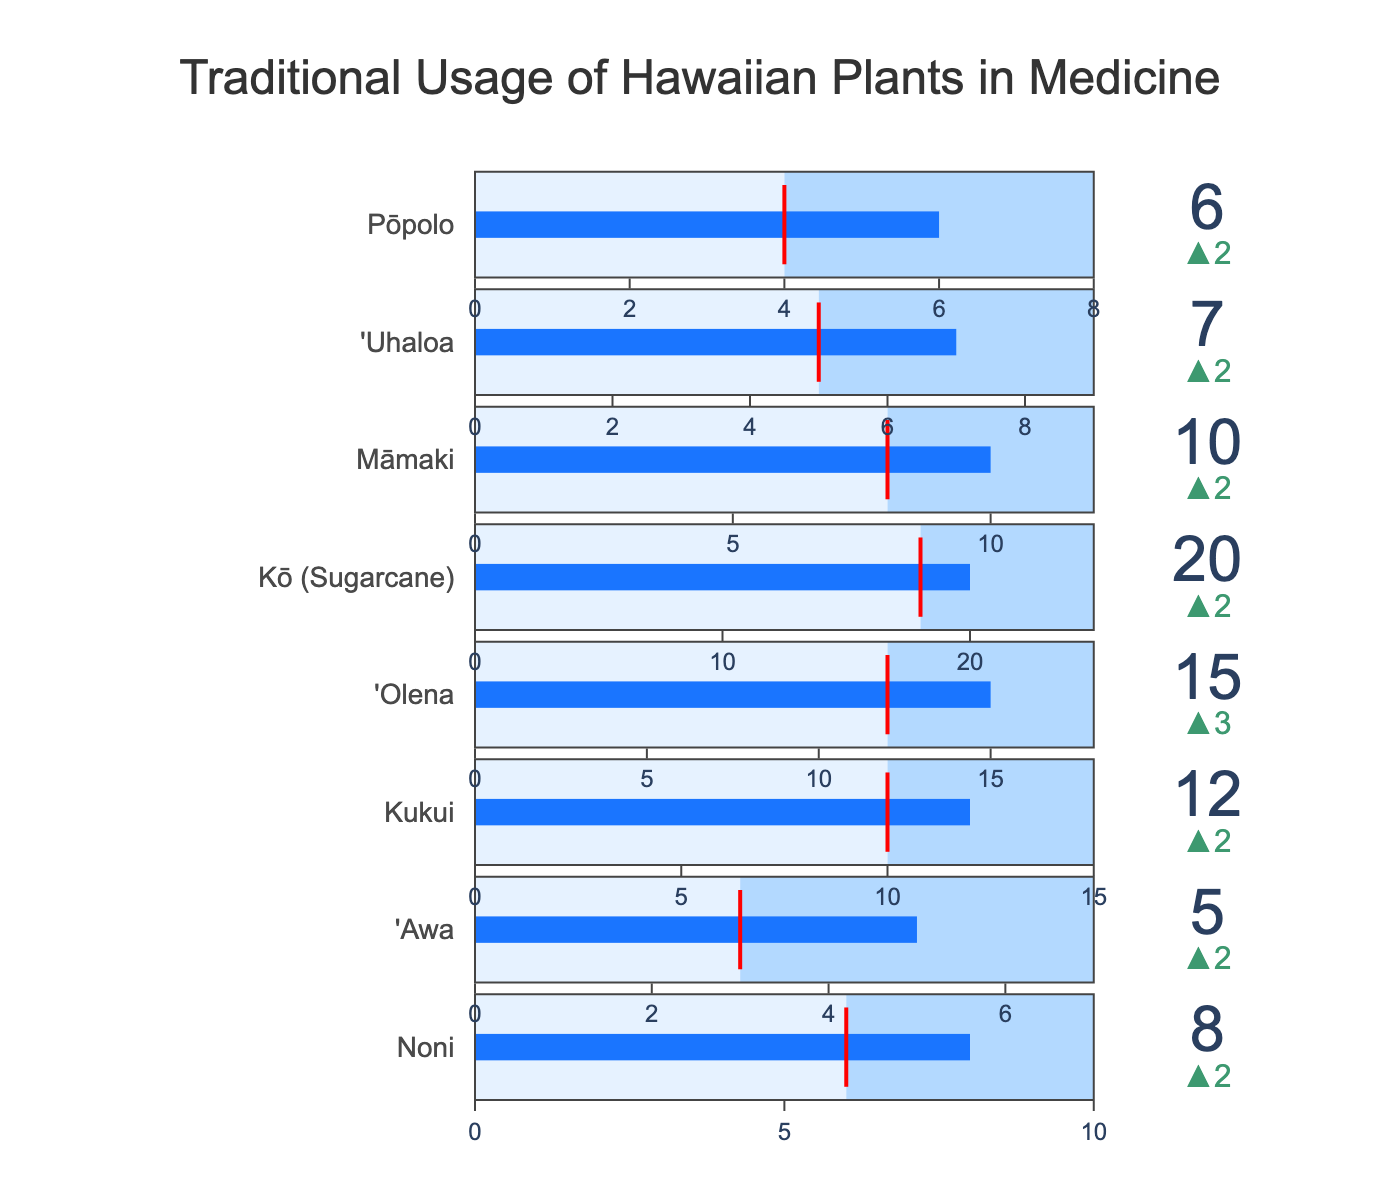what is the title of this figure? The title of the figure is located at the top of the chart. It describes the main subject of the visual representation. By looking at the top of the chart, you will see the text that provides an overview of what the figure is showing.
Answer: Traditional Usage of Hawaiian Plants in Medicine Which plant has the highest actual usage per month? To find the plant with the highest actual usage, compare the values for "Actual Usage (times per month)" for each plant. The plant with the highest value among them is the answer. From the visual data, Kō (Sugarcane) has the highest value.
Answer: Kō (Sugarcane) How many times more is the actual usage than the recommended usage for 'Olena? To determine this, subtract the "Recommended Usage (times per month)" from the "Actual Usage (times per month)" for 'Olena. From the visual data: 15 (Actual) - 12 (Recommended) = 3 times more.
Answer: 3 times more Which plant has the closest actual usage to its recommended usage? To find the plant with the closest actual usage to its recommended usage, calculate the difference between the actual and recommended usage for each plant and find the smallest difference. From the visual data: 'Awa's actual usage is closest to its recommended usage. The difference is 2 (5 - 3).
Answer: 'Awa What is the maximum recommended usage range shown for any plant in the chart? To determine the maximum recommended usage range, look at the maximum usage values of all the plants and find the largest one. The maximum usage range shown is for Kō (Sugarcane), which goes up to 25 times per month.
Answer: 25 times per month Which plant exceeds its recommended usage the most? To determine this, look at the delta values (differences) where the actual usage is higher than the recommended usage and find the largest positive difference. For 'Olena, the actual usage is 15, and the recommended usage is 12. For Kō (Sugarcane), the actual usage is 20, and the recommended usage is 18. The largest positive difference is found by Kō (Sugarcane) with an excess of 2 times.
Answer: Kō (Sugarcane) What is the maximum allowed usage for Kukui? To find the maximum allowed usage for Kukui, look at the value stated in the “Maximum Usage (times per month)” for Kukui. The visual data indicates that the maximum usage for Kukui is 15 times per month.
Answer: 15 times per month What is the difference between actual and recommended usage for Pōpolo? To determine the difference, subtract the recommended usage from the actual usage for Pōpolo. From the visual data: 6 (Actual) - 4 (Recommended) = 2.
Answer: 2 Which plants have actual usage exceeding their maximum allowed usage? To find this, compare the actual usage values with the maximum allowed values for each plant. No plant in the chart exceeds its maximum allowed usage.
Answer: None 